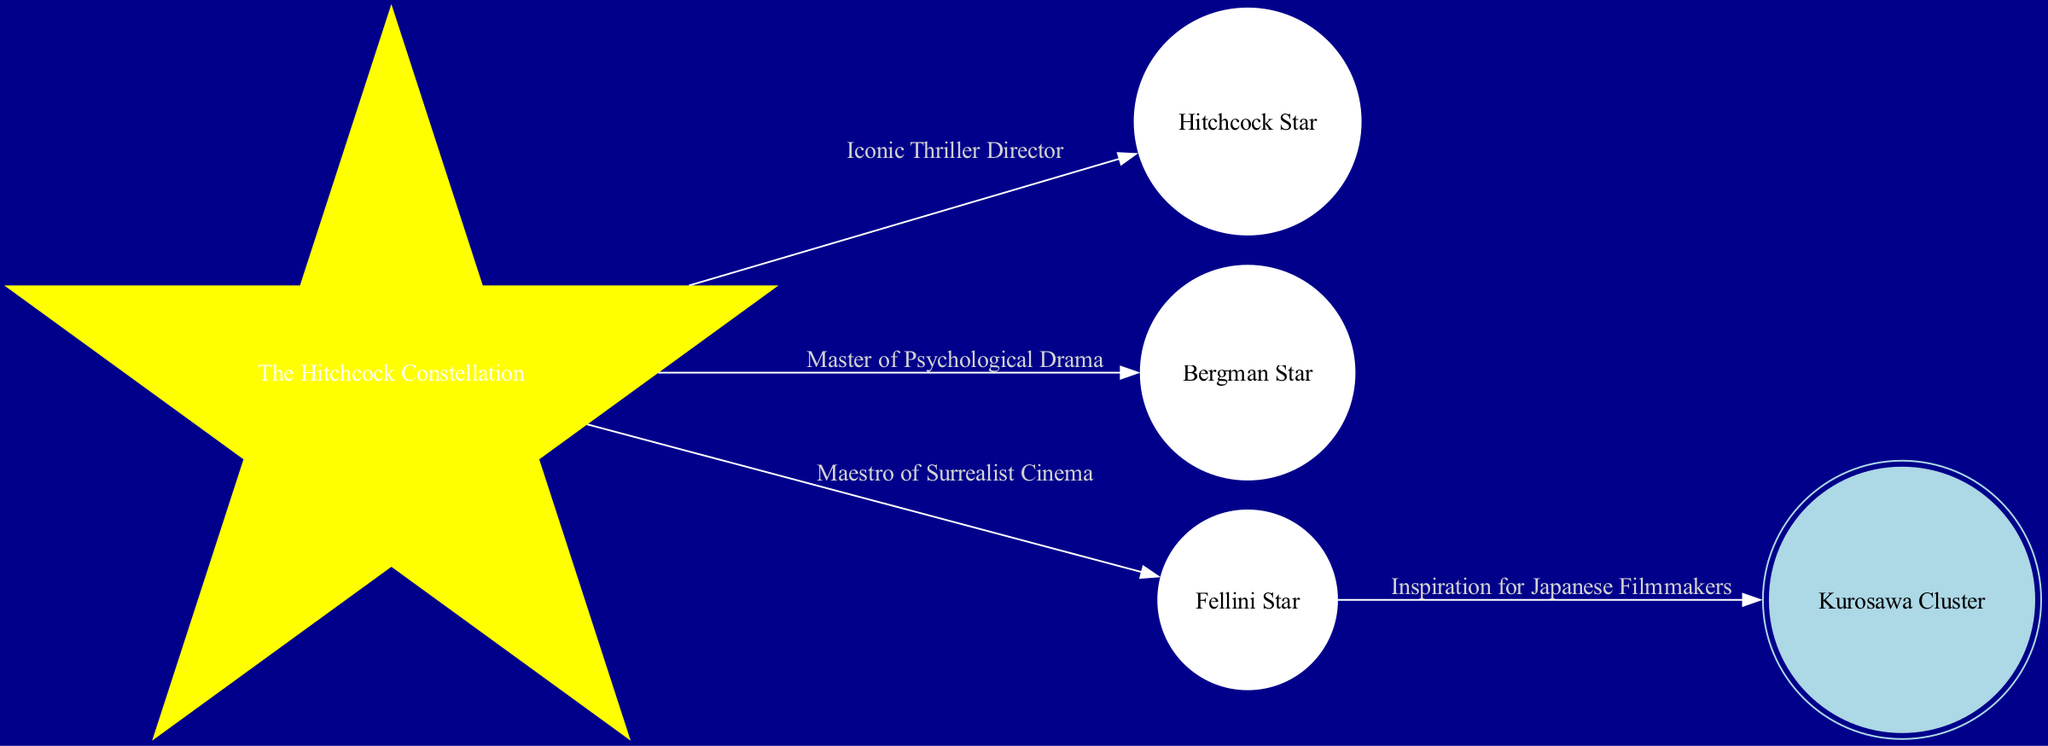What is the name of the constellation in the diagram? The diagram shows a node labeled "The Hitchcock Constellation," which is identified as a constellation. Thus, the name of the constellation is directly visible on the diagram.
Answer: The Hitchcock Constellation How many stars are connected to the Hitchcock Constellation? The diagram displays three stars (Hitchcock Star, Bergman Star, and Fellini Star) that are directly connected to "The Hitchcock Constellation," indicating that these stars are part of this constellation.
Answer: 3 Which star is associated with the label "Iconic Thriller Director"? The edge connected from "The Hitchcock Constellation" to "Hitchcock Star" has the label "Iconic Thriller Director." Therefore, the star associated with this label is Hitchcock Star.
Answer: Hitchcock Star What type of astronomical entity is the Kurosawa Cluster? Based on the node type defined in the diagram, "Kurosawa Cluster" is identified as a cluster. This information can be derived directly from the structure of the node labeled as such.
Answer: cluster What relationship exists between the Fellini Star and the Kurosawa Cluster? The diagram shows an edge connecting "Fellini Star" to "Kurosawa Cluster," with the label "Inspiration for Japanese Filmmakers." This indicates a direct relationship where the Fellini Star is connected to the Kurosawa Cluster and denotes its influence on filmmakers.
Answer: Inspiration for Japanese Filmmakers How many total nodes are represented in the diagram? The diagram lists five nodes: one constellation (The Hitchcock Constellation), three stars (Hitchcock Star, Bergman Star, Fellini Star), and one cluster (Kurosawa Cluster). By counting these, the total number of nodes can be established.
Answer: 5 Which star is linked to the concept of "Maestro of Surrealist Cinema"? The edge connecting the "The Hitchcock Constellation" to "Fellini Star" incorporates the label "Maestro of Surrealist Cinema." Thus, the star linked to this concept is Fellini Star.
Answer: Fellini Star What does the Hitchcock Constellation signify in this diagram? The Hitchcock Constellation signifies a thematic connection to Alfred Hitchcock, represented by the linked stars and their respective influences in cinema as identified by their labels. Thus, it serves as a hub for those notable connections.
Answer: Influence in cinema How many edges are depicted in this diagram? The diagram outlines four edges connecting the nodes: three edges from "The Hitchcock Constellation" to its stars and one edge from "Fellini Star" to "Kurosawa Cluster," allowing us to count the total edges in the graph.
Answer: 4 